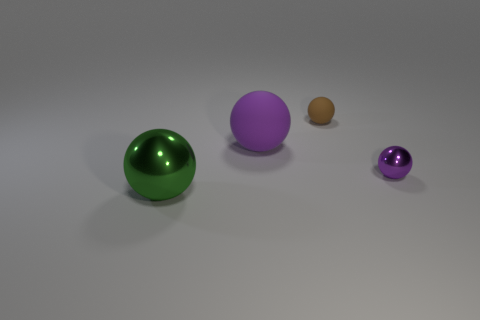Is there any other thing that has the same material as the large green ball?
Your answer should be very brief. Yes. There is a green thing; does it have the same size as the matte object right of the big matte ball?
Offer a very short reply. No. What number of other objects are there of the same color as the large rubber ball?
Provide a short and direct response. 1. Are there any green objects to the right of the tiny brown matte sphere?
Your answer should be compact. No. What number of things are either tiny purple balls or purple objects to the right of the brown rubber ball?
Your answer should be very brief. 1. There is a sphere that is right of the tiny brown thing; is there a tiny thing behind it?
Offer a very short reply. Yes. What shape is the matte object on the left side of the matte sphere that is on the right side of the purple object to the left of the tiny brown matte sphere?
Make the answer very short. Sphere. What color is the object that is in front of the big matte sphere and to the left of the brown object?
Ensure brevity in your answer.  Green. The rubber object that is in front of the brown matte object has what shape?
Give a very brief answer. Sphere. The purple object that is made of the same material as the brown ball is what shape?
Your answer should be very brief. Sphere. 